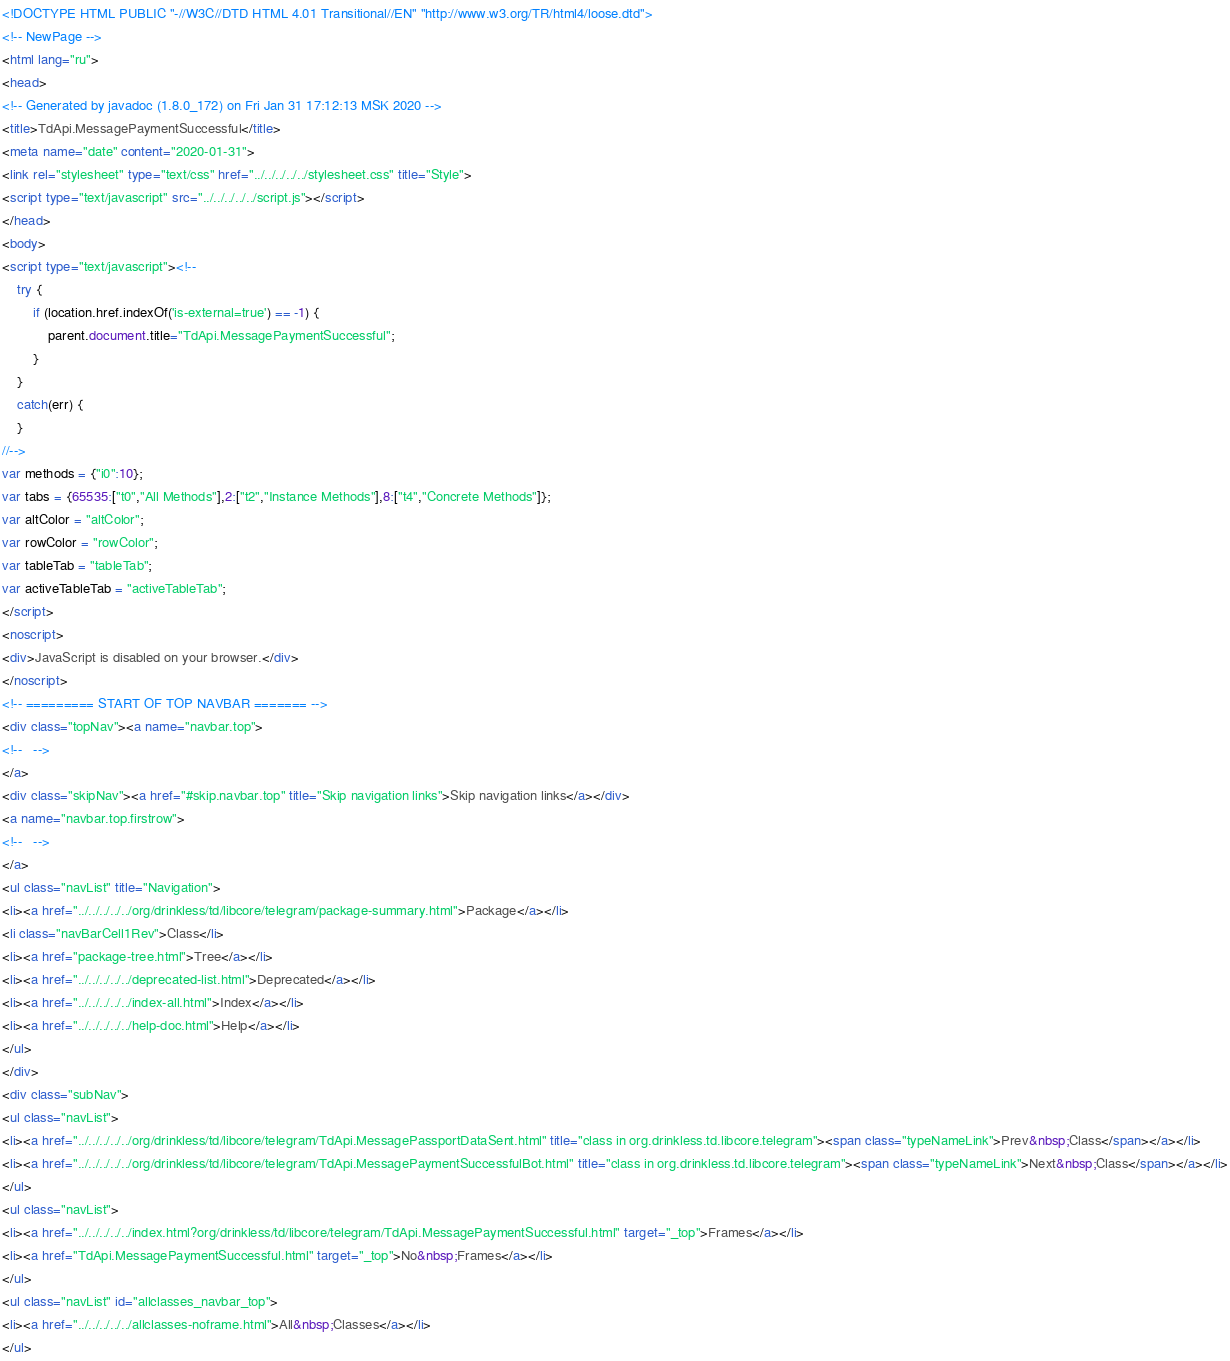Convert code to text. <code><loc_0><loc_0><loc_500><loc_500><_HTML_><!DOCTYPE HTML PUBLIC "-//W3C//DTD HTML 4.01 Transitional//EN" "http://www.w3.org/TR/html4/loose.dtd">
<!-- NewPage -->
<html lang="ru">
<head>
<!-- Generated by javadoc (1.8.0_172) on Fri Jan 31 17:12:13 MSK 2020 -->
<title>TdApi.MessagePaymentSuccessful</title>
<meta name="date" content="2020-01-31">
<link rel="stylesheet" type="text/css" href="../../../../../stylesheet.css" title="Style">
<script type="text/javascript" src="../../../../../script.js"></script>
</head>
<body>
<script type="text/javascript"><!--
    try {
        if (location.href.indexOf('is-external=true') == -1) {
            parent.document.title="TdApi.MessagePaymentSuccessful";
        }
    }
    catch(err) {
    }
//-->
var methods = {"i0":10};
var tabs = {65535:["t0","All Methods"],2:["t2","Instance Methods"],8:["t4","Concrete Methods"]};
var altColor = "altColor";
var rowColor = "rowColor";
var tableTab = "tableTab";
var activeTableTab = "activeTableTab";
</script>
<noscript>
<div>JavaScript is disabled on your browser.</div>
</noscript>
<!-- ========= START OF TOP NAVBAR ======= -->
<div class="topNav"><a name="navbar.top">
<!--   -->
</a>
<div class="skipNav"><a href="#skip.navbar.top" title="Skip navigation links">Skip navigation links</a></div>
<a name="navbar.top.firstrow">
<!--   -->
</a>
<ul class="navList" title="Navigation">
<li><a href="../../../../../org/drinkless/td/libcore/telegram/package-summary.html">Package</a></li>
<li class="navBarCell1Rev">Class</li>
<li><a href="package-tree.html">Tree</a></li>
<li><a href="../../../../../deprecated-list.html">Deprecated</a></li>
<li><a href="../../../../../index-all.html">Index</a></li>
<li><a href="../../../../../help-doc.html">Help</a></li>
</ul>
</div>
<div class="subNav">
<ul class="navList">
<li><a href="../../../../../org/drinkless/td/libcore/telegram/TdApi.MessagePassportDataSent.html" title="class in org.drinkless.td.libcore.telegram"><span class="typeNameLink">Prev&nbsp;Class</span></a></li>
<li><a href="../../../../../org/drinkless/td/libcore/telegram/TdApi.MessagePaymentSuccessfulBot.html" title="class in org.drinkless.td.libcore.telegram"><span class="typeNameLink">Next&nbsp;Class</span></a></li>
</ul>
<ul class="navList">
<li><a href="../../../../../index.html?org/drinkless/td/libcore/telegram/TdApi.MessagePaymentSuccessful.html" target="_top">Frames</a></li>
<li><a href="TdApi.MessagePaymentSuccessful.html" target="_top">No&nbsp;Frames</a></li>
</ul>
<ul class="navList" id="allclasses_navbar_top">
<li><a href="../../../../../allclasses-noframe.html">All&nbsp;Classes</a></li>
</ul></code> 